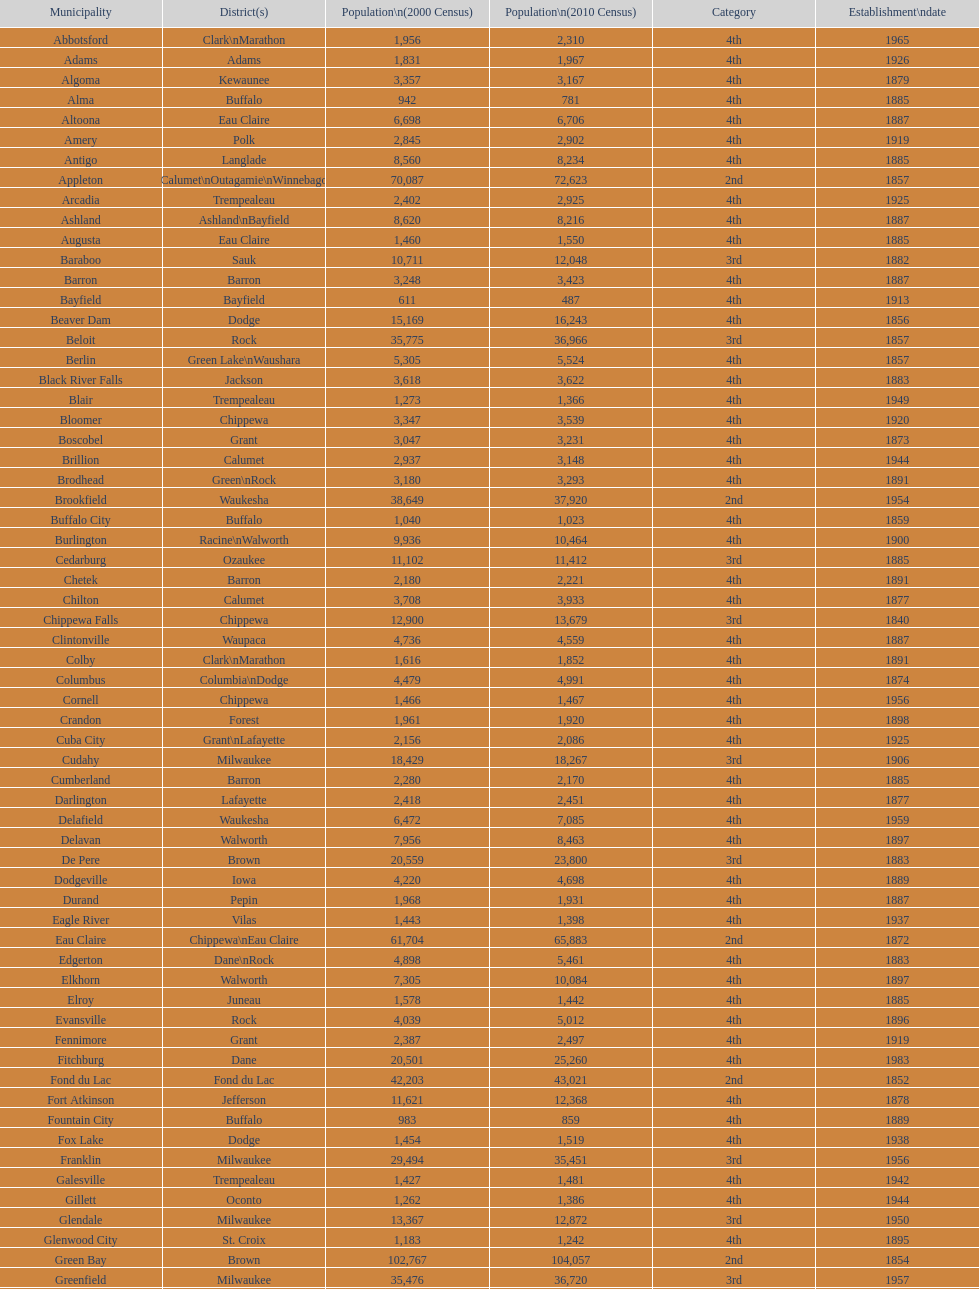Can you give me this table as a dict? {'header': ['Municipality', 'District(s)', 'Population\\n(2000 Census)', 'Population\\n(2010 Census)', 'Category', 'Establishment\\ndate'], 'rows': [['Abbotsford', 'Clark\\nMarathon', '1,956', '2,310', '4th', '1965'], ['Adams', 'Adams', '1,831', '1,967', '4th', '1926'], ['Algoma', 'Kewaunee', '3,357', '3,167', '4th', '1879'], ['Alma', 'Buffalo', '942', '781', '4th', '1885'], ['Altoona', 'Eau Claire', '6,698', '6,706', '4th', '1887'], ['Amery', 'Polk', '2,845', '2,902', '4th', '1919'], ['Antigo', 'Langlade', '8,560', '8,234', '4th', '1885'], ['Appleton', 'Calumet\\nOutagamie\\nWinnebago', '70,087', '72,623', '2nd', '1857'], ['Arcadia', 'Trempealeau', '2,402', '2,925', '4th', '1925'], ['Ashland', 'Ashland\\nBayfield', '8,620', '8,216', '4th', '1887'], ['Augusta', 'Eau Claire', '1,460', '1,550', '4th', '1885'], ['Baraboo', 'Sauk', '10,711', '12,048', '3rd', '1882'], ['Barron', 'Barron', '3,248', '3,423', '4th', '1887'], ['Bayfield', 'Bayfield', '611', '487', '4th', '1913'], ['Beaver Dam', 'Dodge', '15,169', '16,243', '4th', '1856'], ['Beloit', 'Rock', '35,775', '36,966', '3rd', '1857'], ['Berlin', 'Green Lake\\nWaushara', '5,305', '5,524', '4th', '1857'], ['Black River Falls', 'Jackson', '3,618', '3,622', '4th', '1883'], ['Blair', 'Trempealeau', '1,273', '1,366', '4th', '1949'], ['Bloomer', 'Chippewa', '3,347', '3,539', '4th', '1920'], ['Boscobel', 'Grant', '3,047', '3,231', '4th', '1873'], ['Brillion', 'Calumet', '2,937', '3,148', '4th', '1944'], ['Brodhead', 'Green\\nRock', '3,180', '3,293', '4th', '1891'], ['Brookfield', 'Waukesha', '38,649', '37,920', '2nd', '1954'], ['Buffalo City', 'Buffalo', '1,040', '1,023', '4th', '1859'], ['Burlington', 'Racine\\nWalworth', '9,936', '10,464', '4th', '1900'], ['Cedarburg', 'Ozaukee', '11,102', '11,412', '3rd', '1885'], ['Chetek', 'Barron', '2,180', '2,221', '4th', '1891'], ['Chilton', 'Calumet', '3,708', '3,933', '4th', '1877'], ['Chippewa Falls', 'Chippewa', '12,900', '13,679', '3rd', '1840'], ['Clintonville', 'Waupaca', '4,736', '4,559', '4th', '1887'], ['Colby', 'Clark\\nMarathon', '1,616', '1,852', '4th', '1891'], ['Columbus', 'Columbia\\nDodge', '4,479', '4,991', '4th', '1874'], ['Cornell', 'Chippewa', '1,466', '1,467', '4th', '1956'], ['Crandon', 'Forest', '1,961', '1,920', '4th', '1898'], ['Cuba City', 'Grant\\nLafayette', '2,156', '2,086', '4th', '1925'], ['Cudahy', 'Milwaukee', '18,429', '18,267', '3rd', '1906'], ['Cumberland', 'Barron', '2,280', '2,170', '4th', '1885'], ['Darlington', 'Lafayette', '2,418', '2,451', '4th', '1877'], ['Delafield', 'Waukesha', '6,472', '7,085', '4th', '1959'], ['Delavan', 'Walworth', '7,956', '8,463', '4th', '1897'], ['De Pere', 'Brown', '20,559', '23,800', '3rd', '1883'], ['Dodgeville', 'Iowa', '4,220', '4,698', '4th', '1889'], ['Durand', 'Pepin', '1,968', '1,931', '4th', '1887'], ['Eagle River', 'Vilas', '1,443', '1,398', '4th', '1937'], ['Eau Claire', 'Chippewa\\nEau Claire', '61,704', '65,883', '2nd', '1872'], ['Edgerton', 'Dane\\nRock', '4,898', '5,461', '4th', '1883'], ['Elkhorn', 'Walworth', '7,305', '10,084', '4th', '1897'], ['Elroy', 'Juneau', '1,578', '1,442', '4th', '1885'], ['Evansville', 'Rock', '4,039', '5,012', '4th', '1896'], ['Fennimore', 'Grant', '2,387', '2,497', '4th', '1919'], ['Fitchburg', 'Dane', '20,501', '25,260', '4th', '1983'], ['Fond du Lac', 'Fond du Lac', '42,203', '43,021', '2nd', '1852'], ['Fort Atkinson', 'Jefferson', '11,621', '12,368', '4th', '1878'], ['Fountain City', 'Buffalo', '983', '859', '4th', '1889'], ['Fox Lake', 'Dodge', '1,454', '1,519', '4th', '1938'], ['Franklin', 'Milwaukee', '29,494', '35,451', '3rd', '1956'], ['Galesville', 'Trempealeau', '1,427', '1,481', '4th', '1942'], ['Gillett', 'Oconto', '1,262', '1,386', '4th', '1944'], ['Glendale', 'Milwaukee', '13,367', '12,872', '3rd', '1950'], ['Glenwood City', 'St. Croix', '1,183', '1,242', '4th', '1895'], ['Green Bay', 'Brown', '102,767', '104,057', '2nd', '1854'], ['Greenfield', 'Milwaukee', '35,476', '36,720', '3rd', '1957'], ['Green Lake', 'Green Lake', '1,100', '960', '4th', '1962'], ['Greenwood', 'Clark', '1,079', '1,026', '4th', '1891'], ['Hartford', 'Dodge\\nWashington', '10,905', '14,223', '3rd', '1883'], ['Hayward', 'Sawyer', '2,129', '2,318', '4th', '1915'], ['Hillsboro', 'Vernon', '1,302', '1,417', '4th', '1885'], ['Horicon', 'Dodge', '3,775', '3,655', '4th', '1897'], ['Hudson', 'St. Croix', '8,775', '12,719', '4th', '1858'], ['Hurley', 'Iron', '1,818', '1,547', '4th', '1918'], ['Independence', 'Trempealeau', '1,244', '1,336', '4th', '1942'], ['Janesville', 'Rock', '59,498', '63,575', '2nd', '1853'], ['Jefferson', 'Jefferson', '7,338', '7,973', '4th', '1878'], ['Juneau', 'Dodge', '2,485', '2,814', '4th', '1887'], ['Kaukauna', 'Outagamie', '12,983', '15,462', '3rd', '1885'], ['Kenosha', 'Kenosha', '90,352', '99,218', '2nd', '1850'], ['Kewaunee', 'Kewaunee', '2,806', '2,952', '4th', '1883'], ['Kiel', 'Calumet\\nManitowoc', '3,450', '3,738', '4th', '1920'], ['La Crosse', 'La Crosse', '51,818', '51,320', '2nd', '1856'], ['Ladysmith', 'Rusk', '3,932', '3,414', '4th', '1905'], ['Lake Geneva', 'Walworth', '7,148', '7,651', '4th', '1883'], ['Lake Mills', 'Jefferson', '4,843', '5,708', '4th', '1905'], ['Lancaster', 'Grant', '4,070', '3,868', '4th', '1878'], ['Lodi', 'Columbia', '2,882', '3,050', '4th', '1941'], ['Loyal', 'Clark', '1,308', '1,261', '4th', '1948'], ['Madison', 'Dane', '208,054', '233,209', '2nd', '1856'], ['Manawa', 'Waupaca', '1,330', '1,371', '4th', '1954'], ['Manitowoc', 'Manitowoc', '34,053', '33,736', '3rd', '1870'], ['Marinette', 'Marinette', '11,749', '10,968', '3rd', '1887'], ['Marion', 'Shawano\\nWaupaca', '1,297', '1,260', '4th', '1898'], ['Markesan', 'Green Lake', '1,396', '1,476', '4th', '1959'], ['Marshfield', 'Marathon\\nWood', '18,800', '19,118', '3rd', '1883'], ['Mauston', 'Juneau', '3,740', '4,423', '4th', '1883'], ['Mayville', 'Dodge', '4,902', '5,154', '4th', '1885'], ['Medford', 'Taylor', '4,350', '4,326', '4th', '1889'], ['Mellen', 'Ashland', '845', '731', '4th', '1907'], ['Menasha', 'Calumet\\nWinnebago', '16,331', '17,353', '3rd', '1874'], ['Menomonie', 'Dunn', '14,937', '16,264', '4th', '1882'], ['Mequon', 'Ozaukee', '22,643', '23,132', '4th', '1957'], ['Merrill', 'Lincoln', '10,146', '9,661', '4th', '1883'], ['Middleton', 'Dane', '15,770', '17,442', '3rd', '1963'], ['Milton', 'Rock', '5,132', '5,546', '4th', '1969'], ['Milwaukee', 'Milwaukee\\nWashington\\nWaukesha', '596,974', '594,833', '1st', '1846'], ['Mineral Point', 'Iowa', '2,617', '2,487', '4th', '1857'], ['Mondovi', 'Buffalo', '2,634', '2,777', '4th', '1889'], ['Monona', 'Dane', '8,018', '7,533', '4th', '1969'], ['Monroe', 'Green', '10,843', '10,827', '4th', '1882'], ['Montello', 'Marquette', '1,397', '1,495', '4th', '1938'], ['Montreal', 'Iron', '838', '807', '4th', '1924'], ['Mosinee', 'Marathon', '4,063', '3,988', '4th', '1931'], ['Muskego', 'Waukesha', '21,397', '24,135', '3rd', '1964'], ['Neenah', 'Winnebago', '24,507', '25,501', '3rd', '1873'], ['Neillsville', 'Clark', '2,731', '2,463', '4th', '1882'], ['Nekoosa', 'Wood', '2,590', '2,580', '4th', '1926'], ['New Berlin', 'Waukesha', '38,220', '39,584', '3rd', '1959'], ['New Holstein', 'Calumet', '3,301', '3,236', '4th', '1889'], ['New Lisbon', 'Juneau', '1,436', '2,554', '4th', '1889'], ['New London', 'Outagamie\\nWaupaca', '7,085', '7,295', '4th', '1877'], ['New Richmond', 'St. Croix', '6,310', '8,375', '4th', '1885'], ['Niagara', 'Marinette', '1,880', '1,624', '4th', '1992'], ['Oak Creek', 'Milwaukee', '28,456', '34,451', '3rd', '1955'], ['Oconomowoc', 'Waukesha', '12,382', '15,712', '3rd', '1875'], ['Oconto', 'Oconto', '4,708', '4,513', '4th', '1869'], ['Oconto Falls', 'Oconto', '2,843', '2,891', '4th', '1919'], ['Omro', 'Winnebago', '3,177', '3,517', '4th', '1944'], ['Onalaska', 'La Crosse', '14,839', '17,736', '4th', '1887'], ['Oshkosh', 'Winnebago', '62,916', '66,083', '2nd', '1853'], ['Osseo', 'Trempealeau', '1,669', '1,701', '4th', '1941'], ['Owen', 'Clark', '936', '940', '4th', '1925'], ['Park Falls', 'Price', '2,739', '2,462', '4th', '1912'], ['Peshtigo', 'Marinette', '3,474', '3,502', '4th', '1903'], ['Pewaukee', 'Waukesha', '11,783', '13,195', '3rd', '1999'], ['Phillips', 'Price', '1,675', '1,478', '4th', '1891'], ['Pittsville', 'Wood', '866', '874', '4th', '1887'], ['Platteville', 'Grant', '9,989', '11,224', '4th', '1876'], ['Plymouth', 'Sheboygan', '7,781', '8,445', '4th', '1877'], ['Port Washington', 'Ozaukee', '10,467', '11,250', '4th', '1882'], ['Portage', 'Columbia', '9,728', '10,324', '4th', '1854'], ['Prairie du Chien', 'Crawford', '6,018', '5,911', '4th', '1872'], ['Prescott', 'Pierce', '3,764', '4,258', '4th', '1857'], ['Princeton', 'Green Lake', '1,504', '1,214', '4th', '1920'], ['Racine', 'Racine', '81,855', '78,860', '2nd', '1848'], ['Reedsburg', 'Sauk', '7,827', '10,014', '4th', '1887'], ['Rhinelander', 'Oneida', '7,735', '7,798', '4th', '1894'], ['Rice Lake', 'Barron', '8,312', '8,438', '4th', '1887'], ['Richland Center', 'Richland', '5,114', '5,184', '4th', '1887'], ['Ripon', 'Fond du Lac', '7,450', '7,733', '4th', '1858'], ['River Falls', 'Pierce\\nSt. Croix', '12,560', '15,000', '3rd', '1875'], ['St. Croix Falls', 'Polk', '2,033', '2,133', '4th', '1958'], ['St. Francis', 'Milwaukee', '8,662', '9,365', '4th', '1951'], ['Schofield', 'Marathon', '2,117', '2,169', '4th', '1951'], ['Seymour', 'Outagamie', '3,335', '3,451', '4th', '1879'], ['Shawano', 'Shawano', '8,298', '9,305', '4th', '1874'], ['Sheboygan', 'Sheboygan', '50,792', '49,288', '2nd', '1853'], ['Sheboygan Falls', 'Sheboygan', '6,772', '7,775', '4th', '1913'], ['Shell Lake', 'Washburn', '1,309', '1,347', '4th', '1961'], ['Shullsburg', 'Lafayette', '1,246', '1,226', '4th', '1889'], ['South Milwaukee', 'Milwaukee', '21,256', '21,156', '4th', '1897'], ['Sparta', 'Monroe', '8,648', '9,522', '4th', '1883'], ['Spooner', 'Washburn', '2,653', '2,682', '4th', '1909'], ['Stanley', 'Chippewa\\nClark', '1,898', '3,608', '4th', '1898'], ['Stevens Point', 'Portage', '24,551', '26,717', '3rd', '1858'], ['Stoughton', 'Dane', '12,354', '12,611', '4th', '1882'], ['Sturgeon Bay', 'Door', '9,437', '9,144', '4th', '1883'], ['Sun Prairie', 'Dane', '20,369', '29,364', '3rd', '1958'], ['Superior', 'Douglas', '27,368', '27,244', '2nd', '1858'], ['Thorp', 'Clark', '1,536', '1,621', '4th', '1948'], ['Tomah', 'Monroe', '8,419', '9,093', '4th', '1883'], ['Tomahawk', 'Lincoln', '3,770', '3,397', '4th', '1891'], ['Two Rivers', 'Manitowoc', '12,639', '11,712', '3rd', '1878'], ['Verona', 'Dane', '7,052', '10,619', '4th', '1977'], ['Viroqua', 'Vernon', '4,335', '5,079', '4th', '1885'], ['Washburn', 'Bayfield', '2,280', '2,117', '4th', '1904'], ['Waterloo', 'Jefferson', '3,259', '3,333', '4th', '1962'], ['Watertown', 'Dodge\\nJefferson', '21,598', '23,861', '3rd', '1853'], ['Waukesha', 'Waukesha', '64,825', '70,718', '2nd', '1895'], ['Waupaca', 'Waupaca', '5,676', '6,069', '4th', '1878'], ['Waupun', 'Dodge\\nFond du Lac', '10,944', '11,340', '4th', '1878'], ['Wausau', 'Marathon', '38,426', '39,106', '3rd', '1872'], ['Wautoma', 'Waushara', '1,998', '2,218', '4th', '1901'], ['Wauwatosa', 'Milwaukee', '47,271', '46,396', '2nd', '1897'], ['West Allis', 'Milwaukee', '61,254', '60,411', '2nd', '1906'], ['West Bend', 'Washington', '28,152', '31,078', '3rd', '1885'], ['Westby', 'Vernon', '2,045', '2,200', '4th', '1920'], ['Weyauwega', 'Waupaca', '1,806', '1,900', '4th', '1939'], ['Whitehall', 'Trempealeau', '1,651', '1,558', '4th', '1941'], ['Whitewater', 'Jefferson\\nWalworth', '13,437', '14,390', '4th', '1885'], ['Wisconsin Dells', 'Adams\\nColumbia\\nJuneau\\nSauk', '2,418', '2,678', '4th', '1925'], ['Wisconsin Rapids', 'Wood', '18,435', '18,367', '3rd', '1869']]} How many cities are in wisconsin? 190. 